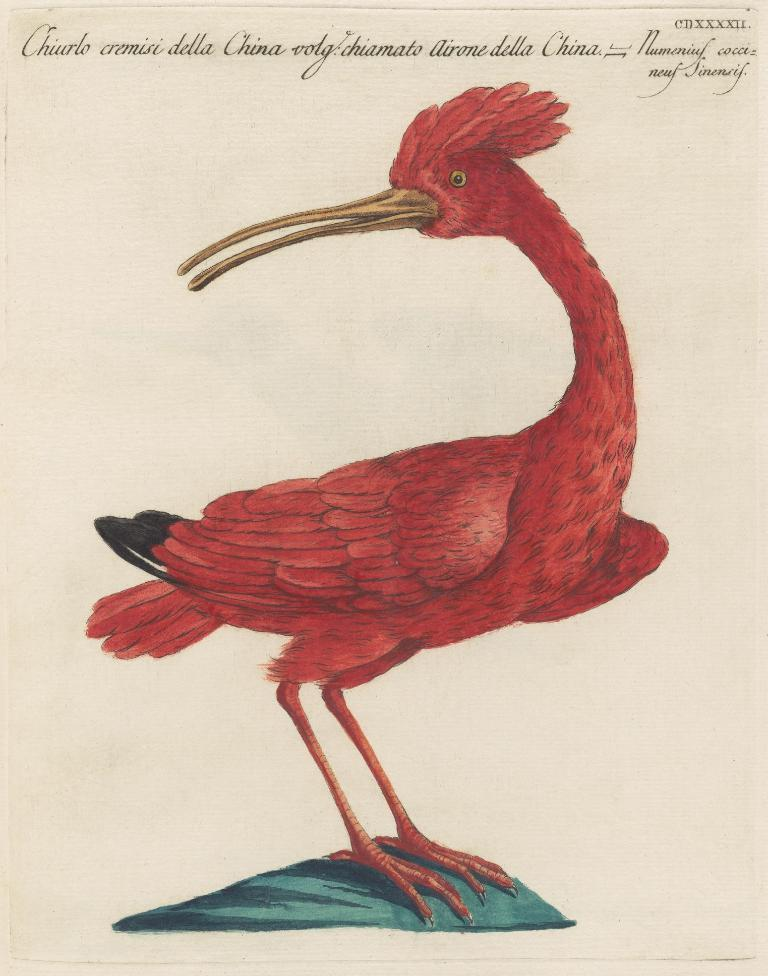What is depicted on the paper in the image? There is a picture of a bird on a paper in the image. What else can be seen at the top of the image? There is text at the top of the image. What type of jar is visible in the image? There is no jar present in the image. Is there any smoke coming from the bird in the image? No, there is no smoke in the image, and the bird is a picture on a paper. 